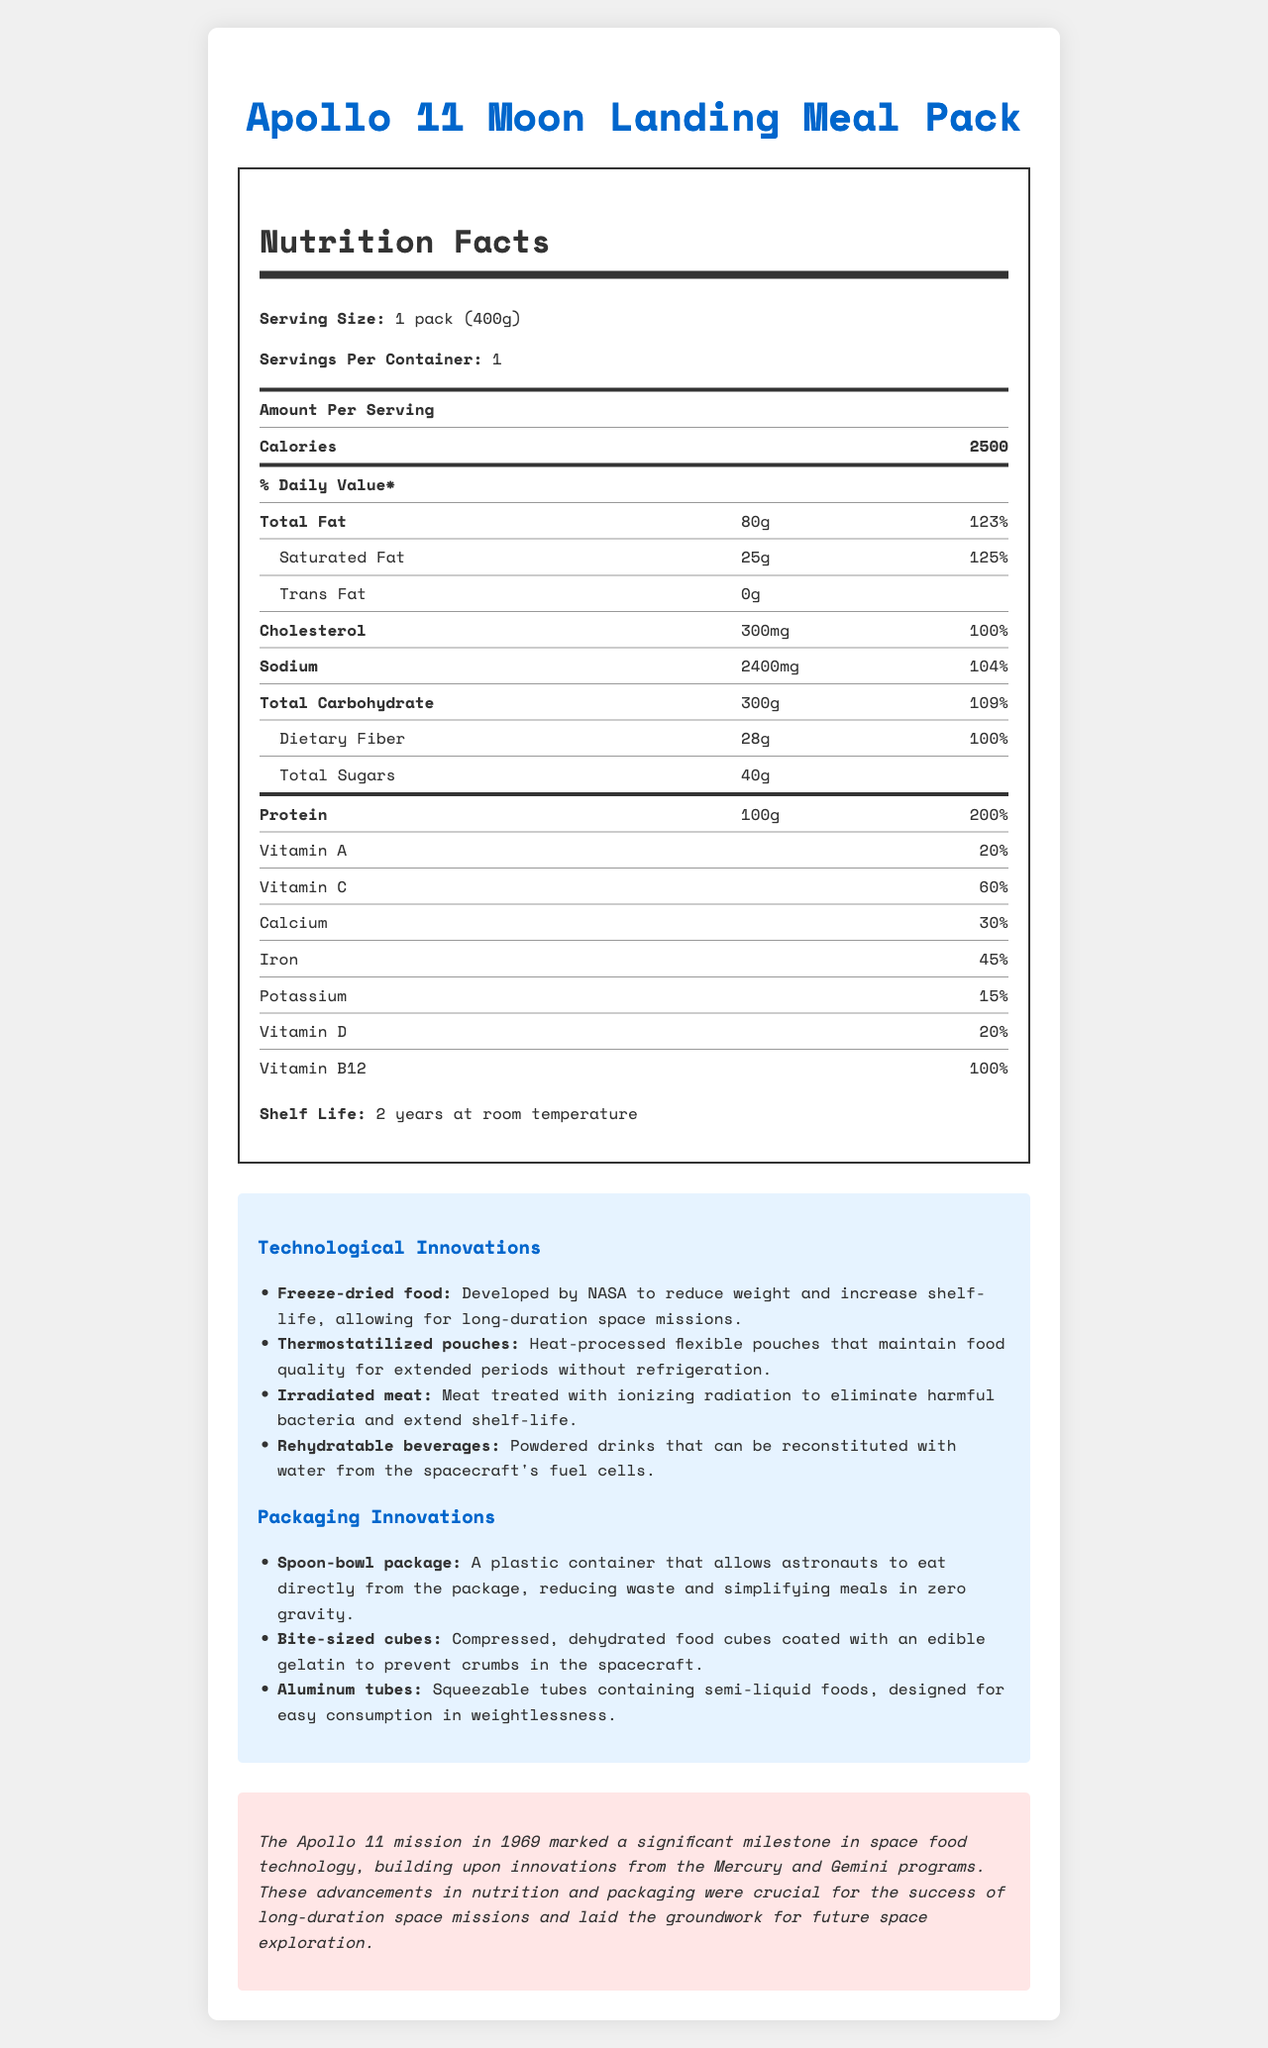what is the serving size of the Apollo 11 Moon Landing Meal Pack? The serving size is explicitly stated in the Nutrition Facts section of the document.
Answer: 1 pack (400g) how many calories are in one serving? The calories per serving are prominently listed in the Nutrition Facts section.
Answer: 2500 name two technological innovations mentioned in the document. The document lists various technological innovations, including freeze-dried food and thermostatilized pouches, in the "Technological Innovations" section.
Answer: Freeze-dried food, Thermostatilized pouches what is the daily value percentage of protein? The daily value percentage of protein is explicitly provided in the Nutrition Facts section under the protein entry.
Answer: 200% how much sodium is there in one serving? The sodium content per serving is listed in the Nutrition Facts section.
Answer: 2400mg what is the shelf life of the Apollo 11 Moon Landing Meal Pack? The shelf life is stated in the Nutrition Facts section.
Answer: 2 years at room temperature what percentage of daily value of vitamin C does the meal pack provide? This information is given in the Nutrition Facts section under the vitamin C entry.
Answer: 60% which packaging innovation helps reduce crumbs in the spacecraft? A. Spoon-bowl package B. Bite-sized cubes C. Aluminum tubes D. Thermostatilized pouches The "Bite-sized cubes" are described as compressed, dehydrated food cubes coated with an edible gelatin to prevent crumbs.
Answer: B what kind of packages allow astronauts to eat directly, reducing waste? A. Irradiated meat B. Aluminum tubes C. Spoon-bowl package D. Rehydratable beverages The "Spoon-bowl package" is designed to allow astronauts to eat directly from the package.
Answer: C could the document tell you how these technological innovations impacted future space missions? The document mentions these innovations were crucial for the success of long-duration space missions but does not detail their exact impact on future missions.
Answer: No does the meal pack contain any trans fat? The document states that the trans fat content is 0g in the Nutrition Facts section.
Answer: No was irradiated meat used as a technological innovation for this space food? Irradiated meat is listed as one of the technological innovations in the document.
Answer: Yes summarize the main idea of the document. The document offers both nutritional information and historical context, highlighting various technological and packaging innovations that made long-duration space missions feasible.
Answer: The document details the Nutrition Facts for the Apollo 11 Moon Landing Meal Pack, emphasizing the technological and packaging innovations developed to ensure food quality and sustainability during space missions. how did NASA ensure meals maintained quality without refrigeration? The thermostatilized pouches are described as heat-processed flexible pouches that keep food quality for extended periods without refrigeration.
Answer: Through thermostatilized pouches which vitamin is provided at 100% daily value in this meal pack? The Nutrition Facts section lists vitamin B12 as being provided at 100% of the daily value.
Answer: Vitamin B12 can you determine exactly how many astronauts consumed this meal pack based on the document? The document does not provide any information about the number of astronauts who consumed the meal pack.
Answer: Cannot be determined 